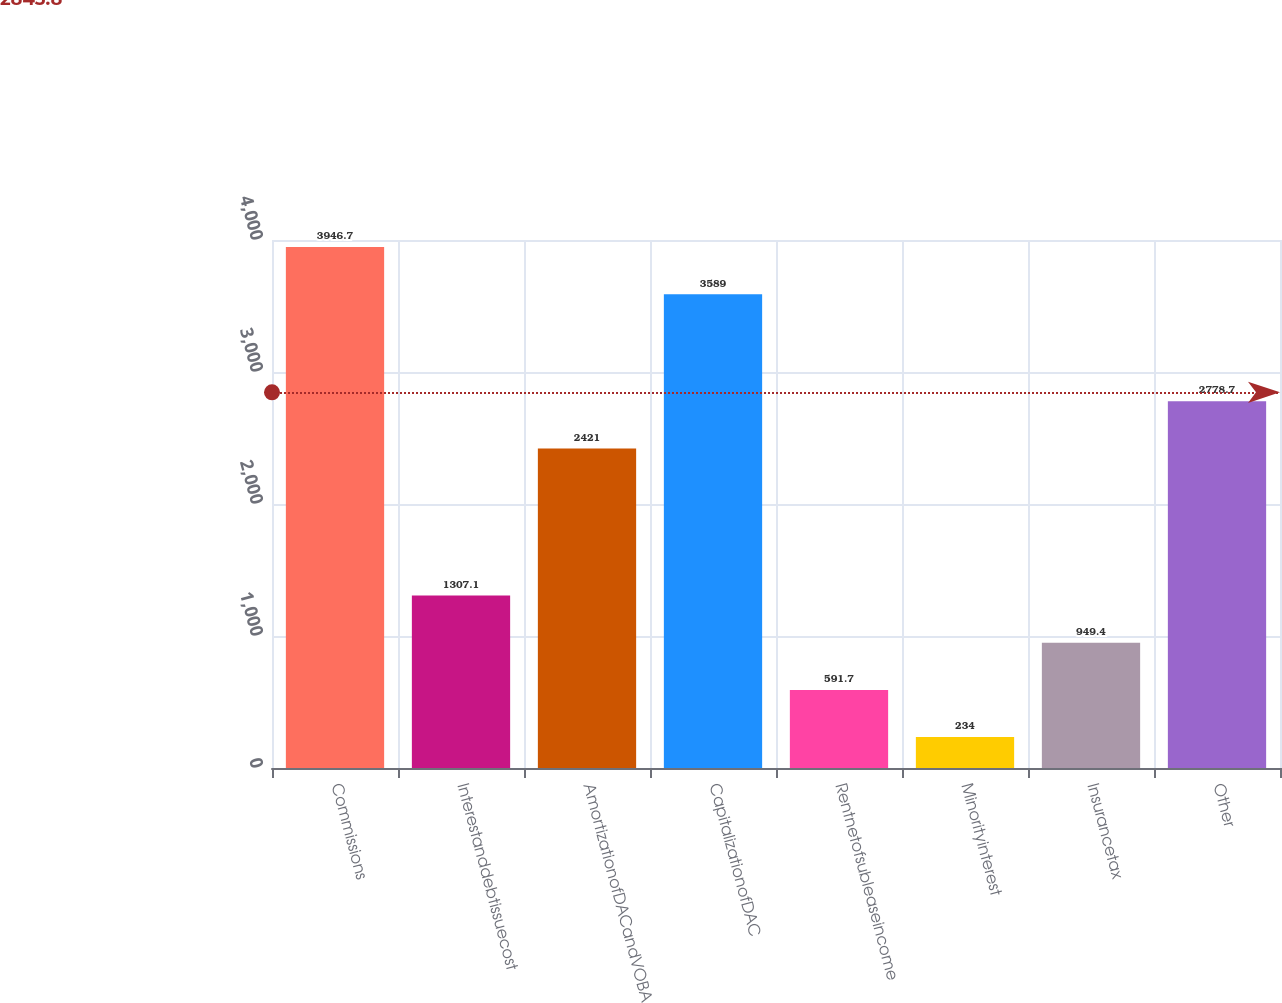Convert chart to OTSL. <chart><loc_0><loc_0><loc_500><loc_500><bar_chart><fcel>Commissions<fcel>Interestanddebtissuecost<fcel>AmortizationofDACandVOBA<fcel>CapitalizationofDAC<fcel>Rentnetofsubleaseincome<fcel>Minorityinterest<fcel>Insurancetax<fcel>Other<nl><fcel>3946.7<fcel>1307.1<fcel>2421<fcel>3589<fcel>591.7<fcel>234<fcel>949.4<fcel>2778.7<nl></chart> 